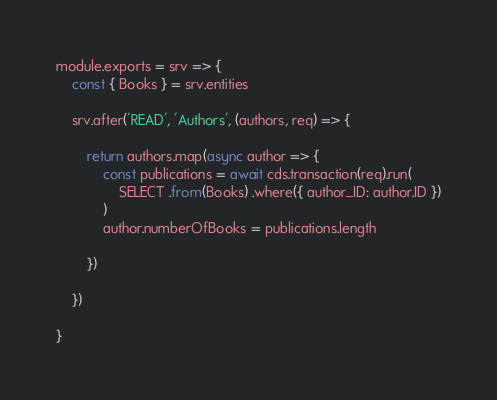Convert code to text. <code><loc_0><loc_0><loc_500><loc_500><_JavaScript_>module.exports = srv => {
	const { Books } = srv.entities

	srv.after('READ', 'Authors', (authors, req) => {

		return authors.map(async author => {
			const publications = await cds.transaction(req).run(
				SELECT .from(Books) .where({ author_ID: author.ID })
			)
			author.numberOfBooks = publications.length

		})

	})

}
</code> 